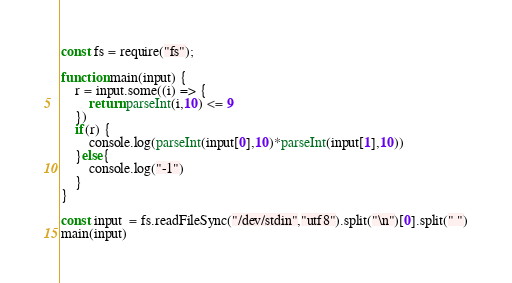Convert code to text. <code><loc_0><loc_0><loc_500><loc_500><_JavaScript_>const fs = require("fs");

function main(input) {
    r = input.some((i) => {
        return parseInt(i,10) <= 9 
    })
    if(r) {
        console.log(parseInt(input[0],10)*parseInt(input[1],10))
    }else{
        console.log("-1")
    }
}

const input  = fs.readFileSync("/dev/stdin","utf8").split("\n")[0].split(" ")
main(input)</code> 